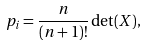Convert formula to latex. <formula><loc_0><loc_0><loc_500><loc_500>p _ { i } = \frac { n } { ( n + 1 ) ! } \det ( X ) ,</formula> 